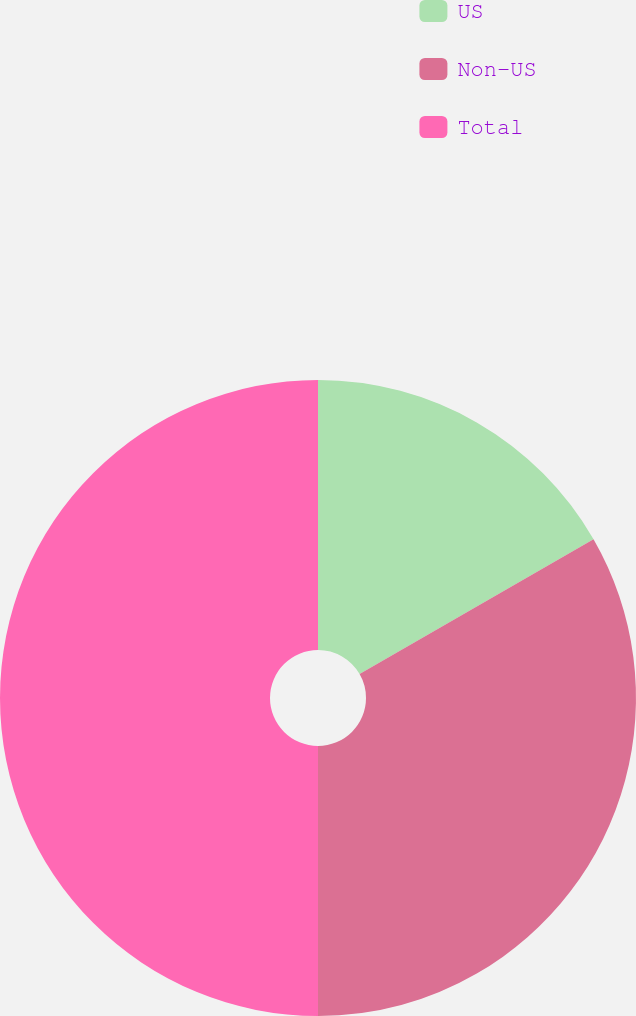Convert chart. <chart><loc_0><loc_0><loc_500><loc_500><pie_chart><fcel>US<fcel>Non-US<fcel>Total<nl><fcel>16.68%<fcel>33.32%<fcel>50.0%<nl></chart> 